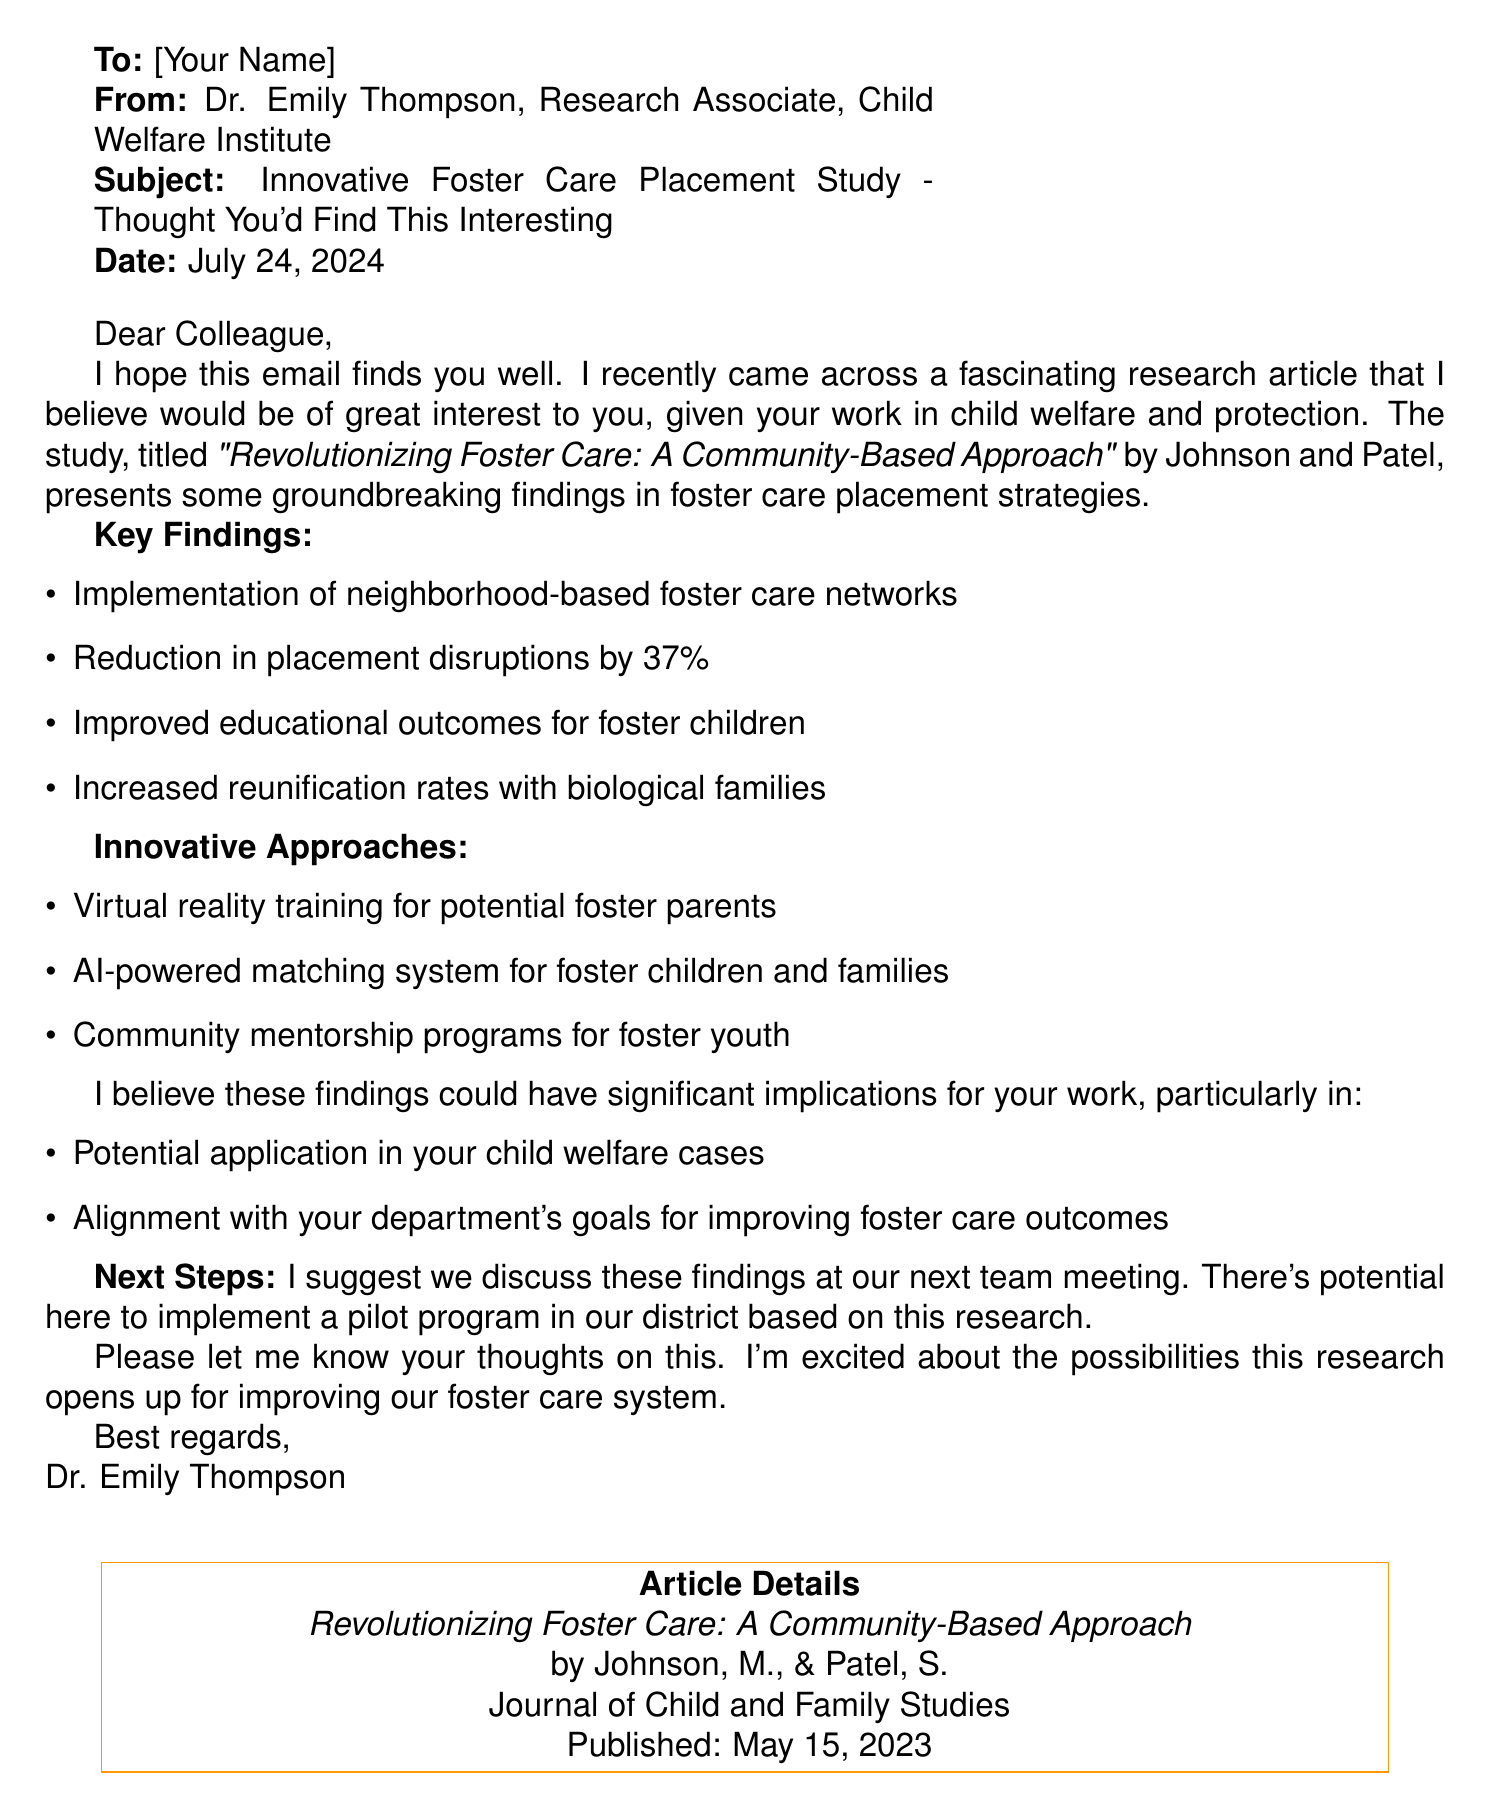What is the title of the research article? The title "Revolutionizing Foster Care: A Community-Based Approach" can be found under Article Details.
Answer: Revolutionizing Foster Care: A Community-Based Approach Who are the authors of the article? The authors Johnson, M., & Patel, S. are mentioned in the Article Details section.
Answer: Johnson, M., & Patel, S When was the article published? The publication date is provided in the Article Details section, which states May 15, 2023.
Answer: May 15, 2023 What percentage reduction in placement disruptions is reported? The key findings section includes a reduction in placement disruptions by 37%.
Answer: 37% What innovative approach involves technology for training foster parents? The innovative approaches detail "Virtual reality training for potential foster parents."
Answer: Virtual reality training What is a suggested next step mentioned in the email? The email proposes discussing the findings at the next team meeting as a suggested next step.
Answer: Discuss findings at next team meeting How might the findings align with department goals? The relevance to the recipient indicates an alignment with improving foster care outcomes.
Answer: Improving foster care outcomes What is one potential outcome of implementing these findings? The call to action section mentions the potential outcome of implementing a pilot program in the district.
Answer: Implement pilot program in our district What is the journal in which the article was published? The journal name is listed in the Article Details section as Journal of Child and Family Studies.
Answer: Journal of Child and Family Studies 